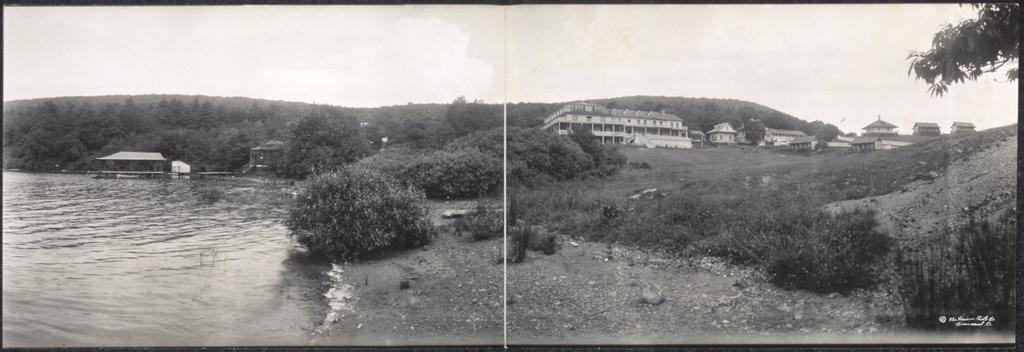What is the color scheme of the image? The image is black and white. What type of structures can be seen in the image? There are buildings in the image. What natural elements are present in the image? There are trees and water visible in the image. What type of vegetation is present in the image? There are plants in the image. What is visible in the background of the image? The sky is visible in the background of the image. Can you see any corks floating in the water in the image? There are no corks visible in the image; it only features buildings, trees, water, plants, and the sky. How many toes are visible in the image? There are no toes present in the image. 